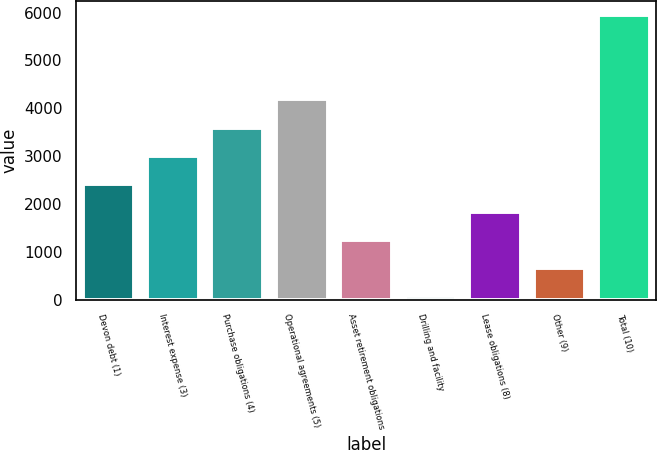Convert chart to OTSL. <chart><loc_0><loc_0><loc_500><loc_500><bar_chart><fcel>Devon debt (1)<fcel>Interest expense (3)<fcel>Purchase obligations (4)<fcel>Operational agreements (5)<fcel>Asset retirement obligations<fcel>Drilling and facility<fcel>Lease obligations (8)<fcel>Other (9)<fcel>Total (10)<nl><fcel>2428.6<fcel>3014.5<fcel>3600.4<fcel>4186.3<fcel>1256.8<fcel>85<fcel>1842.7<fcel>670.9<fcel>5944<nl></chart> 